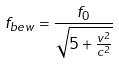<formula> <loc_0><loc_0><loc_500><loc_500>f _ { b e w } = \frac { f _ { 0 } } { \sqrt { 5 + \frac { v ^ { 2 } } { c ^ { 2 } } } }</formula> 